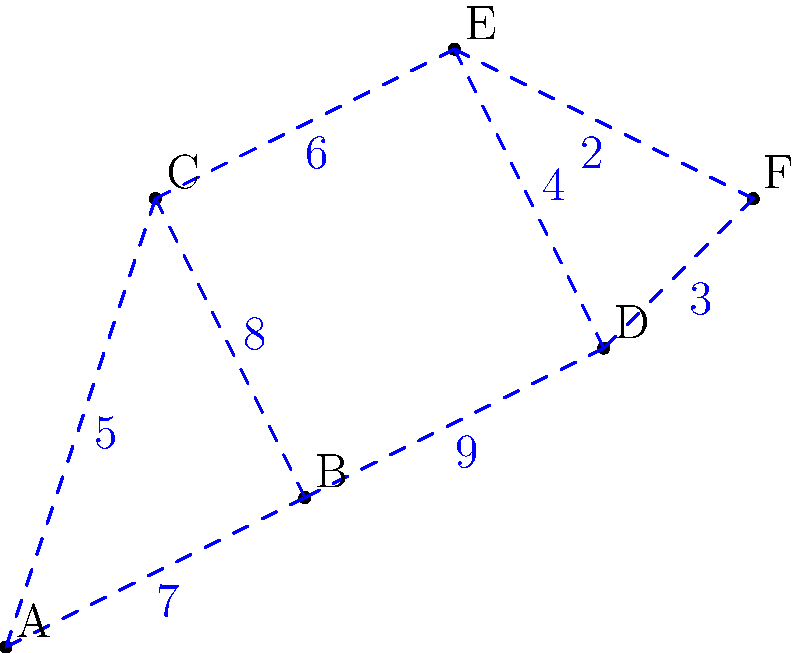As an extreme sports enthusiast planning the ultimate multi-site adventure, you need to connect six outdoor locations (A, B, C, D, E, F) with the minimum total distance for your epic challenge. Given the distances between connected sites as shown in the diagram, what is the total distance of the minimum spanning tree that connects all locations? To find the minimum spanning tree, we'll use Kruskal's algorithm:

1. Sort all edges by weight (distance) in ascending order:
   E-F (2), D-F (3), D-E (4), A-C (5), C-E (6), A-B (7), B-C (8), B-D (9)

2. Start with an empty set and add edges that don't create cycles:
   - Add E-F (2)
   - Add D-F (3)
   - Add D-E (4) (skip, creates a cycle)
   - Add A-C (5)
   - Add C-E (6)
   - Add A-B (7) (completes the tree)

3. The minimum spanning tree consists of edges:
   E-F (2), D-F (3), A-C (5), C-E (6), A-B (7)

4. Calculate the total distance:
   $$2 + 3 + 5 + 6 + 7 = 23$$

Therefore, the total distance of the minimum spanning tree is 23 units.
Answer: 23 units 